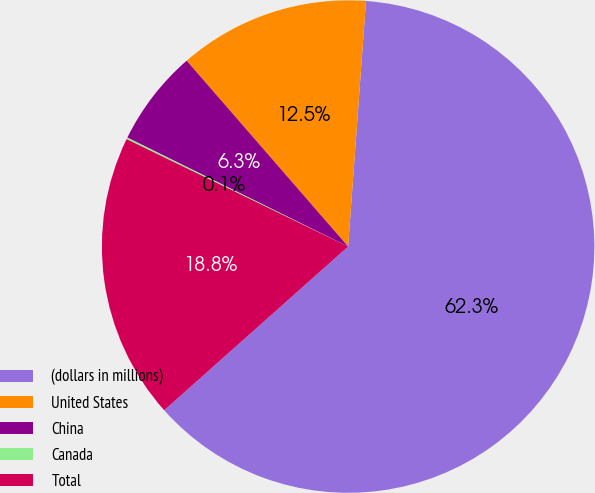Convert chart. <chart><loc_0><loc_0><loc_500><loc_500><pie_chart><fcel>(dollars in millions)<fcel>United States<fcel>China<fcel>Canada<fcel>Total<nl><fcel>62.27%<fcel>12.54%<fcel>6.32%<fcel>0.11%<fcel>18.76%<nl></chart> 